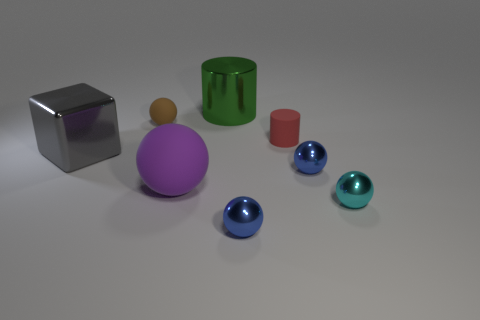Subtract 2 balls. How many balls are left? 3 Subtract all large purple spheres. How many spheres are left? 4 Subtract all cyan balls. How many balls are left? 4 Subtract all yellow balls. Subtract all green blocks. How many balls are left? 5 Add 1 big red metal objects. How many objects exist? 9 Subtract all purple shiny cylinders. Subtract all gray blocks. How many objects are left? 7 Add 8 green metal cylinders. How many green metal cylinders are left? 9 Add 1 big purple balls. How many big purple balls exist? 2 Subtract 0 yellow cubes. How many objects are left? 8 Subtract all cylinders. How many objects are left? 6 